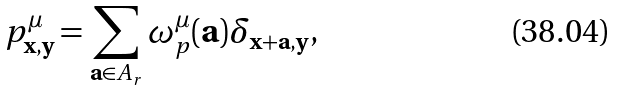Convert formula to latex. <formula><loc_0><loc_0><loc_500><loc_500>p ^ { \mu } _ { { \mathbf x } , { \mathbf y } } = \sum _ { { \mathbf a } \in A _ { r } } \omega ^ { \mu } _ { p } ( { \mathbf a } ) \delta _ { { \mathbf x } + { \mathbf a } , { \mathbf y } } ,</formula> 